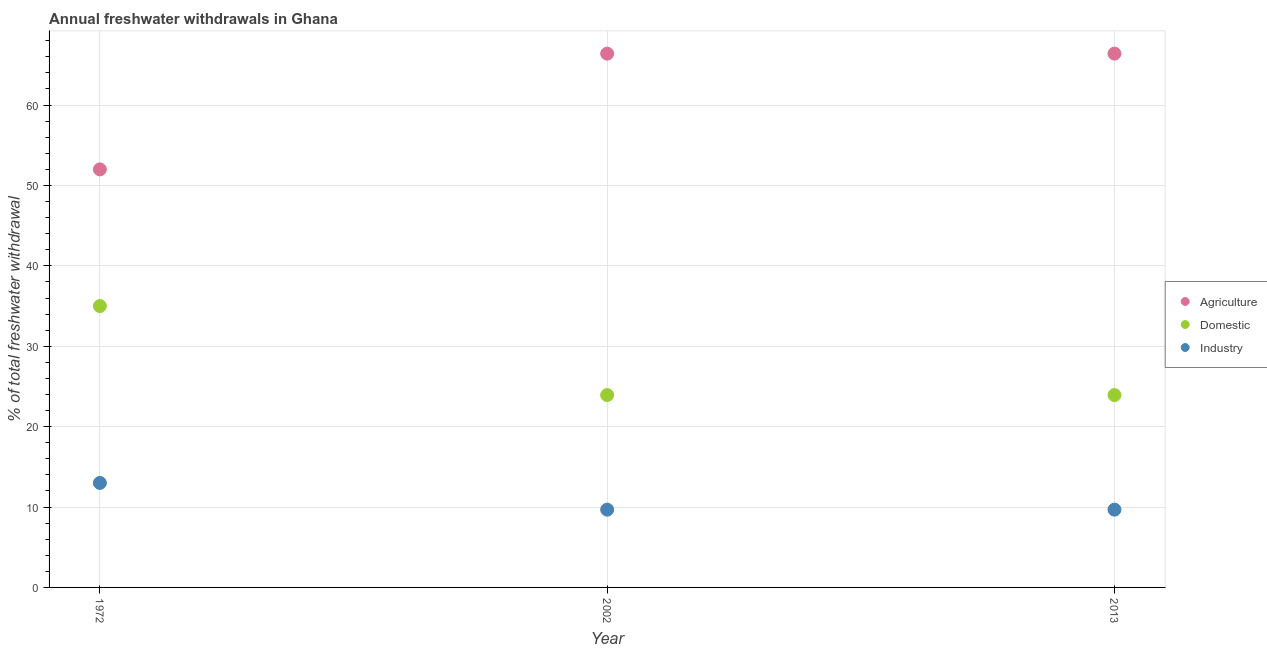How many different coloured dotlines are there?
Ensure brevity in your answer.  3. Is the number of dotlines equal to the number of legend labels?
Offer a very short reply. Yes. What is the percentage of freshwater withdrawal for industry in 1972?
Provide a succinct answer. 13. Across all years, what is the maximum percentage of freshwater withdrawal for agriculture?
Ensure brevity in your answer.  66.4. Across all years, what is the minimum percentage of freshwater withdrawal for domestic purposes?
Your answer should be compact. 23.93. What is the total percentage of freshwater withdrawal for domestic purposes in the graph?
Provide a short and direct response. 82.86. What is the difference between the percentage of freshwater withdrawal for industry in 1972 and that in 2013?
Your response must be concise. 3.33. What is the difference between the percentage of freshwater withdrawal for industry in 2013 and the percentage of freshwater withdrawal for domestic purposes in 2002?
Your answer should be compact. -14.26. What is the average percentage of freshwater withdrawal for domestic purposes per year?
Make the answer very short. 27.62. In the year 2013, what is the difference between the percentage of freshwater withdrawal for industry and percentage of freshwater withdrawal for agriculture?
Provide a short and direct response. -56.73. In how many years, is the percentage of freshwater withdrawal for agriculture greater than 28 %?
Offer a terse response. 3. What is the ratio of the percentage of freshwater withdrawal for agriculture in 1972 to that in 2013?
Offer a terse response. 0.78. What is the difference between the highest and the second highest percentage of freshwater withdrawal for domestic purposes?
Your answer should be very brief. 11.07. What is the difference between the highest and the lowest percentage of freshwater withdrawal for industry?
Offer a very short reply. 3.33. Is it the case that in every year, the sum of the percentage of freshwater withdrawal for agriculture and percentage of freshwater withdrawal for domestic purposes is greater than the percentage of freshwater withdrawal for industry?
Your response must be concise. Yes. Is the percentage of freshwater withdrawal for industry strictly greater than the percentage of freshwater withdrawal for domestic purposes over the years?
Give a very brief answer. No. How many dotlines are there?
Provide a short and direct response. 3. How many years are there in the graph?
Your answer should be compact. 3. What is the difference between two consecutive major ticks on the Y-axis?
Make the answer very short. 10. Are the values on the major ticks of Y-axis written in scientific E-notation?
Keep it short and to the point. No. Does the graph contain any zero values?
Offer a terse response. No. Where does the legend appear in the graph?
Your answer should be very brief. Center right. What is the title of the graph?
Ensure brevity in your answer.  Annual freshwater withdrawals in Ghana. What is the label or title of the X-axis?
Your answer should be very brief. Year. What is the label or title of the Y-axis?
Keep it short and to the point. % of total freshwater withdrawal. What is the % of total freshwater withdrawal of Domestic in 1972?
Give a very brief answer. 35. What is the % of total freshwater withdrawal of Industry in 1972?
Ensure brevity in your answer.  13. What is the % of total freshwater withdrawal in Agriculture in 2002?
Give a very brief answer. 66.4. What is the % of total freshwater withdrawal in Domestic in 2002?
Your answer should be compact. 23.93. What is the % of total freshwater withdrawal in Industry in 2002?
Make the answer very short. 9.67. What is the % of total freshwater withdrawal of Agriculture in 2013?
Ensure brevity in your answer.  66.4. What is the % of total freshwater withdrawal in Domestic in 2013?
Ensure brevity in your answer.  23.93. What is the % of total freshwater withdrawal in Industry in 2013?
Provide a short and direct response. 9.67. Across all years, what is the maximum % of total freshwater withdrawal in Agriculture?
Provide a succinct answer. 66.4. Across all years, what is the minimum % of total freshwater withdrawal in Agriculture?
Provide a short and direct response. 52. Across all years, what is the minimum % of total freshwater withdrawal in Domestic?
Give a very brief answer. 23.93. Across all years, what is the minimum % of total freshwater withdrawal of Industry?
Keep it short and to the point. 9.67. What is the total % of total freshwater withdrawal in Agriculture in the graph?
Provide a short and direct response. 184.8. What is the total % of total freshwater withdrawal of Domestic in the graph?
Give a very brief answer. 82.86. What is the total % of total freshwater withdrawal in Industry in the graph?
Offer a very short reply. 32.35. What is the difference between the % of total freshwater withdrawal of Agriculture in 1972 and that in 2002?
Give a very brief answer. -14.4. What is the difference between the % of total freshwater withdrawal of Domestic in 1972 and that in 2002?
Your response must be concise. 11.07. What is the difference between the % of total freshwater withdrawal of Industry in 1972 and that in 2002?
Offer a very short reply. 3.33. What is the difference between the % of total freshwater withdrawal of Agriculture in 1972 and that in 2013?
Your response must be concise. -14.4. What is the difference between the % of total freshwater withdrawal in Domestic in 1972 and that in 2013?
Your answer should be very brief. 11.07. What is the difference between the % of total freshwater withdrawal of Industry in 1972 and that in 2013?
Ensure brevity in your answer.  3.33. What is the difference between the % of total freshwater withdrawal of Agriculture in 2002 and that in 2013?
Your response must be concise. 0. What is the difference between the % of total freshwater withdrawal in Industry in 2002 and that in 2013?
Keep it short and to the point. 0. What is the difference between the % of total freshwater withdrawal in Agriculture in 1972 and the % of total freshwater withdrawal in Domestic in 2002?
Your answer should be compact. 28.07. What is the difference between the % of total freshwater withdrawal of Agriculture in 1972 and the % of total freshwater withdrawal of Industry in 2002?
Ensure brevity in your answer.  42.33. What is the difference between the % of total freshwater withdrawal in Domestic in 1972 and the % of total freshwater withdrawal in Industry in 2002?
Make the answer very short. 25.33. What is the difference between the % of total freshwater withdrawal of Agriculture in 1972 and the % of total freshwater withdrawal of Domestic in 2013?
Offer a terse response. 28.07. What is the difference between the % of total freshwater withdrawal in Agriculture in 1972 and the % of total freshwater withdrawal in Industry in 2013?
Provide a succinct answer. 42.33. What is the difference between the % of total freshwater withdrawal of Domestic in 1972 and the % of total freshwater withdrawal of Industry in 2013?
Provide a succinct answer. 25.33. What is the difference between the % of total freshwater withdrawal of Agriculture in 2002 and the % of total freshwater withdrawal of Domestic in 2013?
Your answer should be compact. 42.47. What is the difference between the % of total freshwater withdrawal in Agriculture in 2002 and the % of total freshwater withdrawal in Industry in 2013?
Your response must be concise. 56.73. What is the difference between the % of total freshwater withdrawal in Domestic in 2002 and the % of total freshwater withdrawal in Industry in 2013?
Offer a very short reply. 14.26. What is the average % of total freshwater withdrawal in Agriculture per year?
Ensure brevity in your answer.  61.6. What is the average % of total freshwater withdrawal of Domestic per year?
Offer a terse response. 27.62. What is the average % of total freshwater withdrawal of Industry per year?
Your answer should be very brief. 10.78. In the year 1972, what is the difference between the % of total freshwater withdrawal of Domestic and % of total freshwater withdrawal of Industry?
Give a very brief answer. 22. In the year 2002, what is the difference between the % of total freshwater withdrawal of Agriculture and % of total freshwater withdrawal of Domestic?
Your response must be concise. 42.47. In the year 2002, what is the difference between the % of total freshwater withdrawal of Agriculture and % of total freshwater withdrawal of Industry?
Make the answer very short. 56.73. In the year 2002, what is the difference between the % of total freshwater withdrawal of Domestic and % of total freshwater withdrawal of Industry?
Provide a short and direct response. 14.26. In the year 2013, what is the difference between the % of total freshwater withdrawal of Agriculture and % of total freshwater withdrawal of Domestic?
Ensure brevity in your answer.  42.47. In the year 2013, what is the difference between the % of total freshwater withdrawal in Agriculture and % of total freshwater withdrawal in Industry?
Ensure brevity in your answer.  56.73. In the year 2013, what is the difference between the % of total freshwater withdrawal of Domestic and % of total freshwater withdrawal of Industry?
Provide a short and direct response. 14.26. What is the ratio of the % of total freshwater withdrawal of Agriculture in 1972 to that in 2002?
Your response must be concise. 0.78. What is the ratio of the % of total freshwater withdrawal in Domestic in 1972 to that in 2002?
Your answer should be compact. 1.46. What is the ratio of the % of total freshwater withdrawal in Industry in 1972 to that in 2002?
Give a very brief answer. 1.34. What is the ratio of the % of total freshwater withdrawal in Agriculture in 1972 to that in 2013?
Your response must be concise. 0.78. What is the ratio of the % of total freshwater withdrawal in Domestic in 1972 to that in 2013?
Provide a short and direct response. 1.46. What is the ratio of the % of total freshwater withdrawal in Industry in 1972 to that in 2013?
Provide a succinct answer. 1.34. What is the ratio of the % of total freshwater withdrawal of Domestic in 2002 to that in 2013?
Ensure brevity in your answer.  1. What is the ratio of the % of total freshwater withdrawal in Industry in 2002 to that in 2013?
Offer a terse response. 1. What is the difference between the highest and the second highest % of total freshwater withdrawal of Domestic?
Your answer should be compact. 11.07. What is the difference between the highest and the second highest % of total freshwater withdrawal of Industry?
Offer a very short reply. 3.33. What is the difference between the highest and the lowest % of total freshwater withdrawal of Domestic?
Make the answer very short. 11.07. What is the difference between the highest and the lowest % of total freshwater withdrawal of Industry?
Your answer should be very brief. 3.33. 